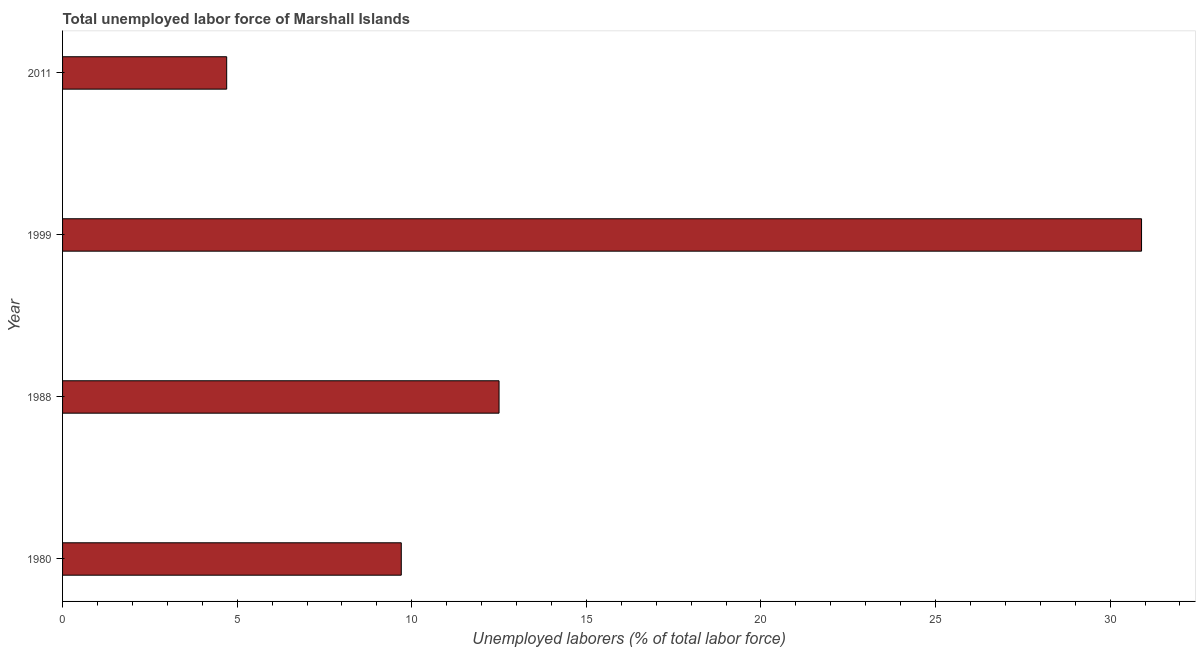What is the title of the graph?
Provide a short and direct response. Total unemployed labor force of Marshall Islands. What is the label or title of the X-axis?
Provide a short and direct response. Unemployed laborers (% of total labor force). What is the total unemployed labour force in 1988?
Your answer should be compact. 12.5. Across all years, what is the maximum total unemployed labour force?
Provide a short and direct response. 30.9. Across all years, what is the minimum total unemployed labour force?
Keep it short and to the point. 4.7. In which year was the total unemployed labour force maximum?
Your answer should be very brief. 1999. What is the sum of the total unemployed labour force?
Your answer should be very brief. 57.8. What is the difference between the total unemployed labour force in 1980 and 1988?
Give a very brief answer. -2.8. What is the average total unemployed labour force per year?
Offer a very short reply. 14.45. What is the median total unemployed labour force?
Your answer should be compact. 11.1. In how many years, is the total unemployed labour force greater than 4 %?
Your answer should be compact. 4. Do a majority of the years between 1988 and 1980 (inclusive) have total unemployed labour force greater than 7 %?
Your response must be concise. No. What is the ratio of the total unemployed labour force in 1999 to that in 2011?
Provide a short and direct response. 6.57. Is the difference between the total unemployed labour force in 1980 and 1988 greater than the difference between any two years?
Offer a very short reply. No. Is the sum of the total unemployed labour force in 1980 and 1988 greater than the maximum total unemployed labour force across all years?
Provide a succinct answer. No. What is the difference between the highest and the lowest total unemployed labour force?
Your answer should be very brief. 26.2. How many years are there in the graph?
Ensure brevity in your answer.  4. Are the values on the major ticks of X-axis written in scientific E-notation?
Ensure brevity in your answer.  No. What is the Unemployed laborers (% of total labor force) in 1980?
Keep it short and to the point. 9.7. What is the Unemployed laborers (% of total labor force) in 1999?
Your answer should be compact. 30.9. What is the Unemployed laborers (% of total labor force) in 2011?
Your answer should be compact. 4.7. What is the difference between the Unemployed laborers (% of total labor force) in 1980 and 1988?
Your response must be concise. -2.8. What is the difference between the Unemployed laborers (% of total labor force) in 1980 and 1999?
Your response must be concise. -21.2. What is the difference between the Unemployed laborers (% of total labor force) in 1988 and 1999?
Ensure brevity in your answer.  -18.4. What is the difference between the Unemployed laborers (% of total labor force) in 1999 and 2011?
Give a very brief answer. 26.2. What is the ratio of the Unemployed laborers (% of total labor force) in 1980 to that in 1988?
Keep it short and to the point. 0.78. What is the ratio of the Unemployed laborers (% of total labor force) in 1980 to that in 1999?
Provide a succinct answer. 0.31. What is the ratio of the Unemployed laborers (% of total labor force) in 1980 to that in 2011?
Offer a terse response. 2.06. What is the ratio of the Unemployed laborers (% of total labor force) in 1988 to that in 1999?
Ensure brevity in your answer.  0.41. What is the ratio of the Unemployed laborers (% of total labor force) in 1988 to that in 2011?
Make the answer very short. 2.66. What is the ratio of the Unemployed laborers (% of total labor force) in 1999 to that in 2011?
Offer a terse response. 6.57. 